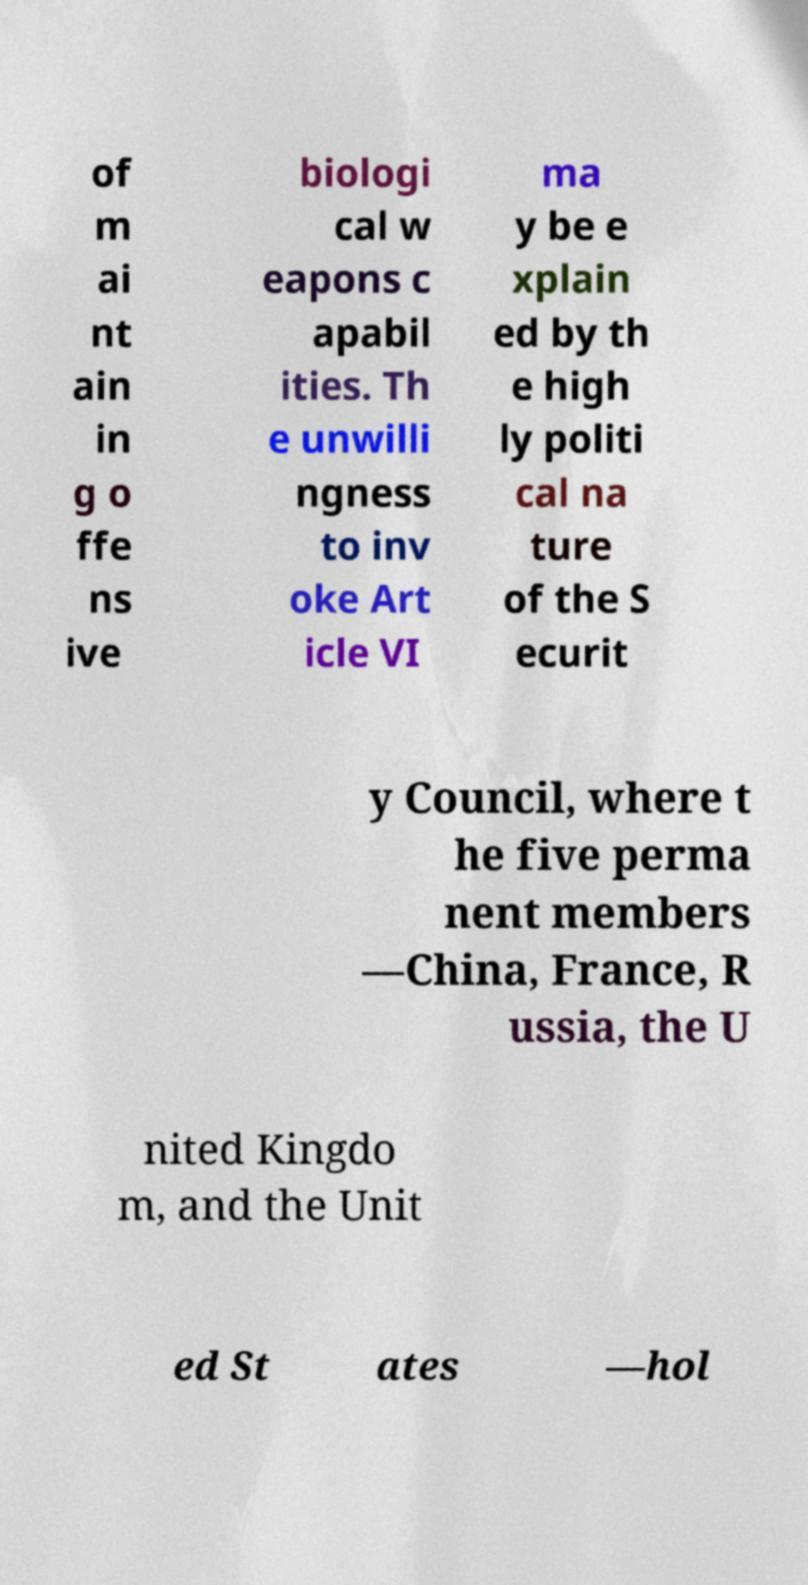Can you read and provide the text displayed in the image?This photo seems to have some interesting text. Can you extract and type it out for me? of m ai nt ain in g o ffe ns ive biologi cal w eapons c apabil ities. Th e unwilli ngness to inv oke Art icle VI ma y be e xplain ed by th e high ly politi cal na ture of the S ecurit y Council, where t he five perma nent members —China, France, R ussia, the U nited Kingdo m, and the Unit ed St ates —hol 